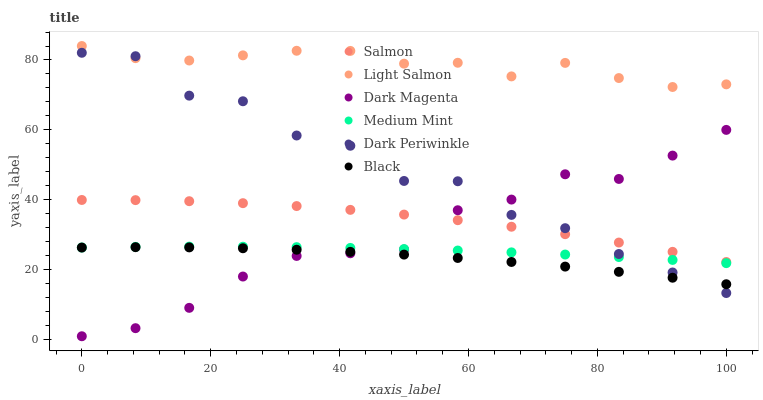Does Black have the minimum area under the curve?
Answer yes or no. Yes. Does Light Salmon have the maximum area under the curve?
Answer yes or no. Yes. Does Dark Magenta have the minimum area under the curve?
Answer yes or no. No. Does Dark Magenta have the maximum area under the curve?
Answer yes or no. No. Is Medium Mint the smoothest?
Answer yes or no. Yes. Is Dark Periwinkle the roughest?
Answer yes or no. Yes. Is Light Salmon the smoothest?
Answer yes or no. No. Is Light Salmon the roughest?
Answer yes or no. No. Does Dark Magenta have the lowest value?
Answer yes or no. Yes. Does Light Salmon have the lowest value?
Answer yes or no. No. Does Light Salmon have the highest value?
Answer yes or no. Yes. Does Dark Magenta have the highest value?
Answer yes or no. No. Is Black less than Light Salmon?
Answer yes or no. Yes. Is Salmon greater than Black?
Answer yes or no. Yes. Does Dark Magenta intersect Black?
Answer yes or no. Yes. Is Dark Magenta less than Black?
Answer yes or no. No. Is Dark Magenta greater than Black?
Answer yes or no. No. Does Black intersect Light Salmon?
Answer yes or no. No. 